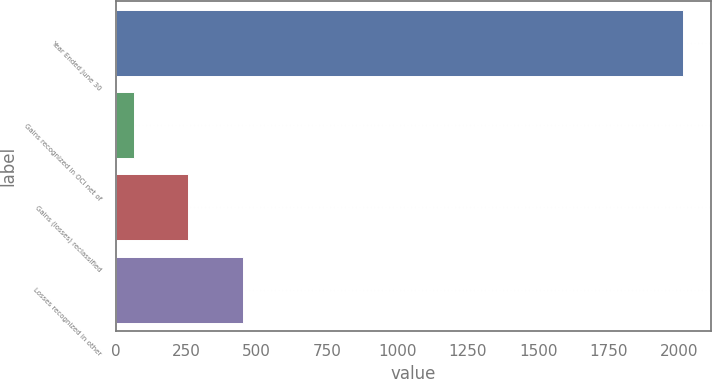Convert chart. <chart><loc_0><loc_0><loc_500><loc_500><bar_chart><fcel>Year Ended June 30<fcel>Gains recognized in OCI net of<fcel>Gains (losses) reclassified<fcel>Losses recognized in other<nl><fcel>2014<fcel>63<fcel>258.1<fcel>453.2<nl></chart> 